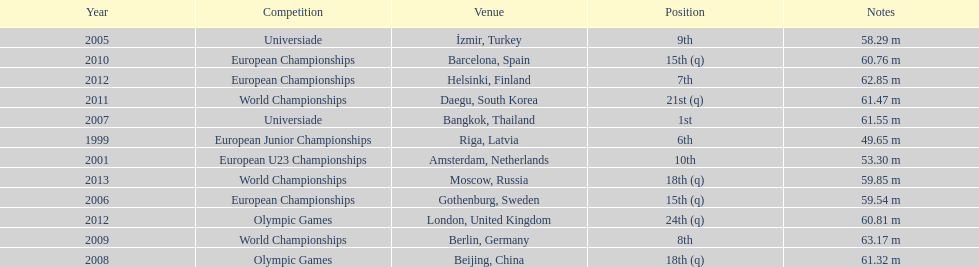How what listed year was a distance of only 53.30m reached? 2001. 